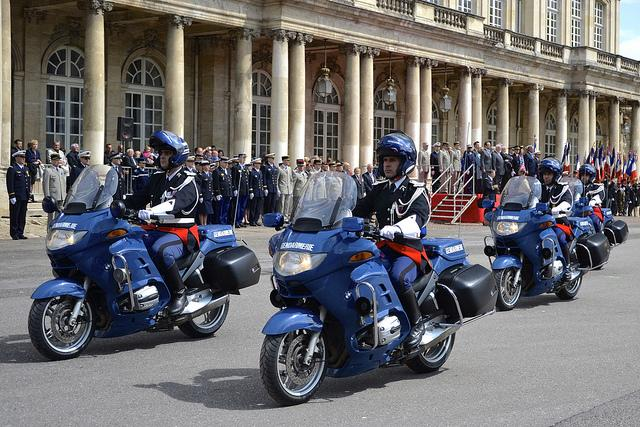What type of outfit are the men on the motorcycles wearing? uniform 